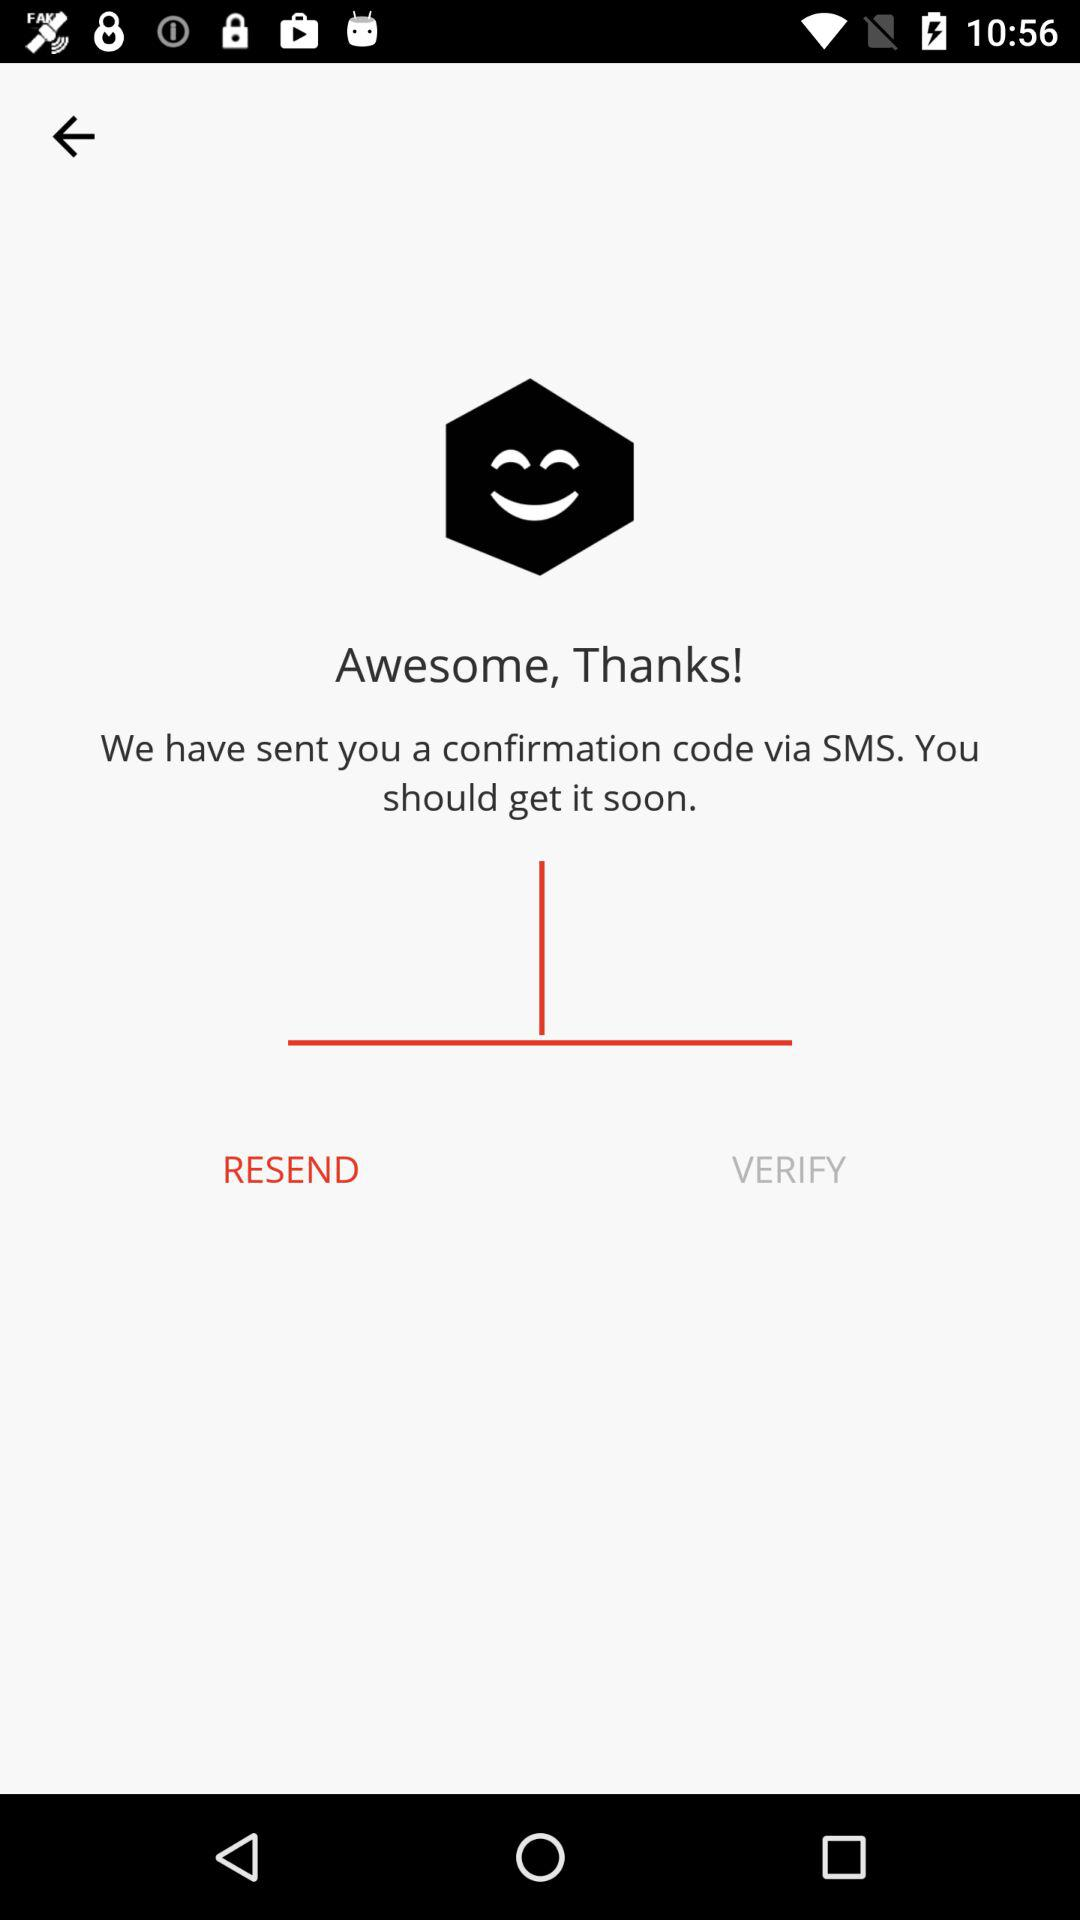Through what mode did the confirmation code get sent? The confirmation code was sent through SMS. 